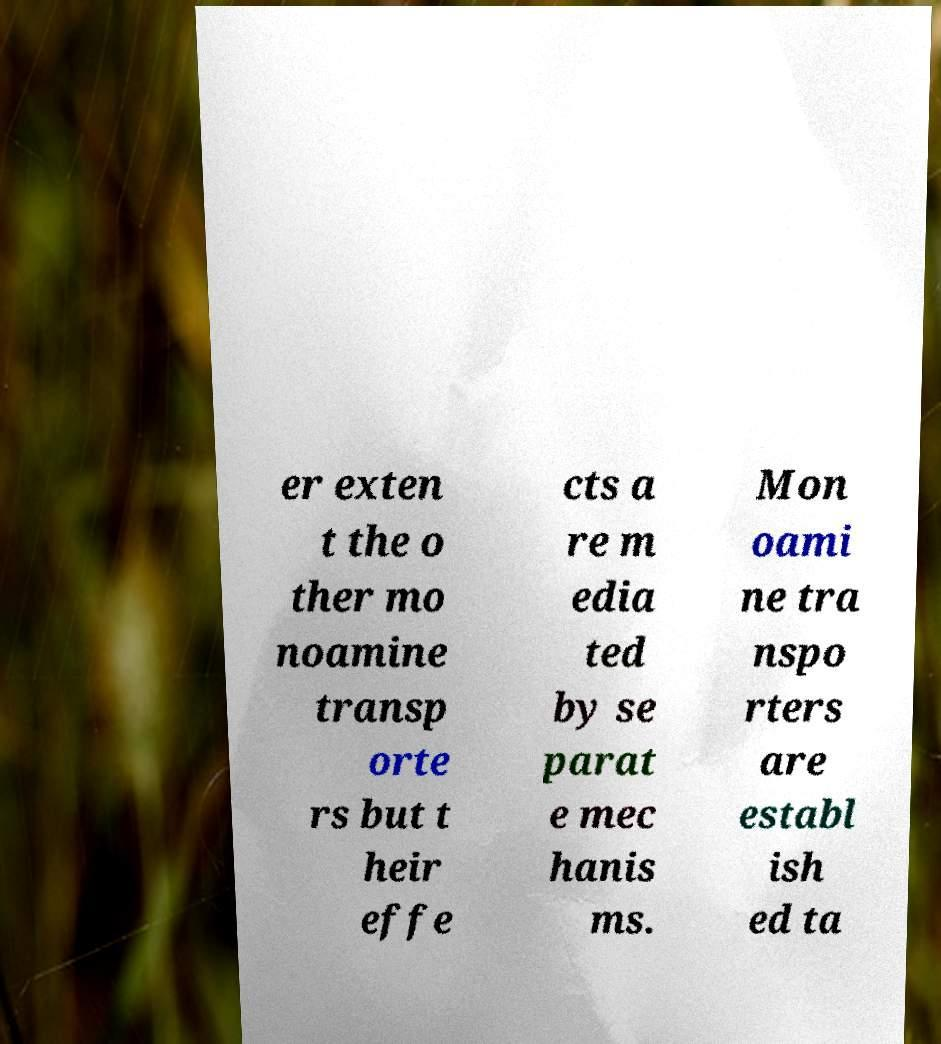For documentation purposes, I need the text within this image transcribed. Could you provide that? er exten t the o ther mo noamine transp orte rs but t heir effe cts a re m edia ted by se parat e mec hanis ms. Mon oami ne tra nspo rters are establ ish ed ta 